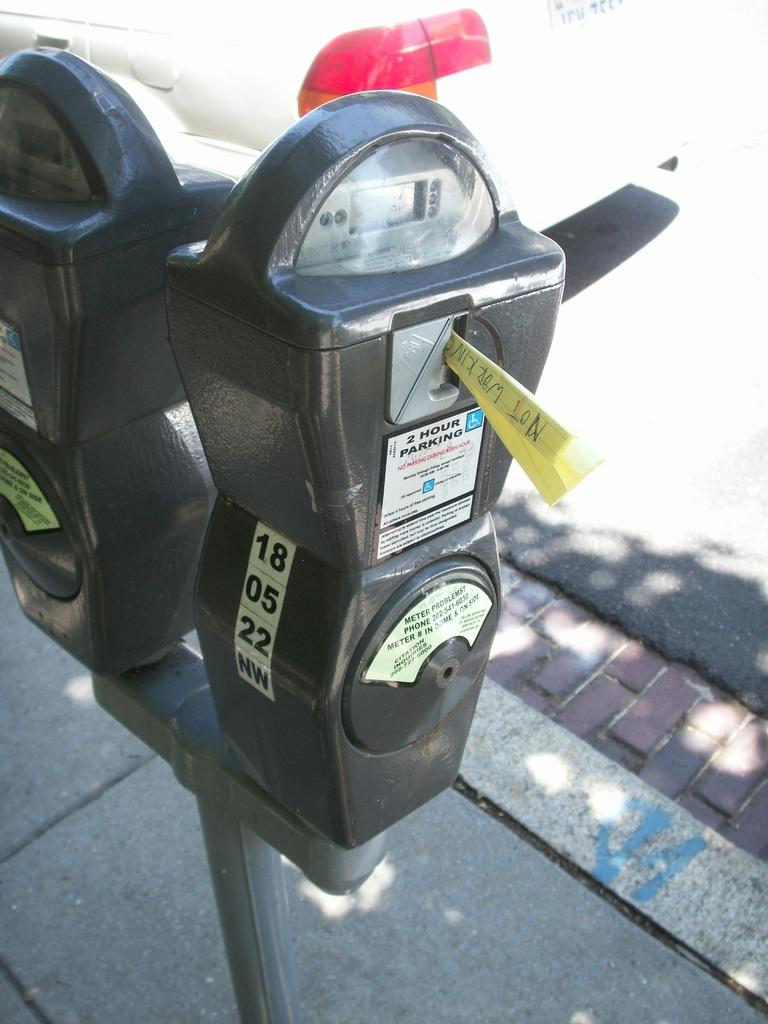<image>
Write a terse but informative summary of the picture. a meter that has the number 18 at the top of it 